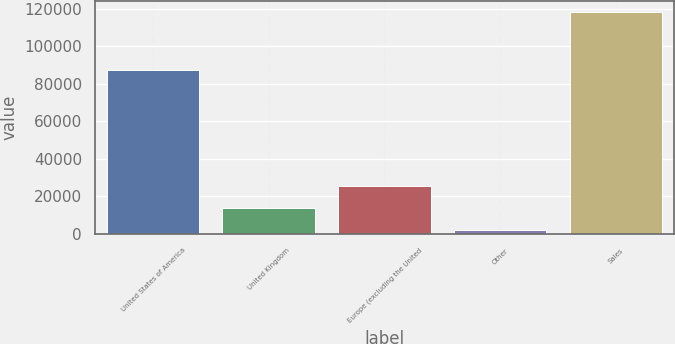Convert chart to OTSL. <chart><loc_0><loc_0><loc_500><loc_500><bar_chart><fcel>United States of America<fcel>United Kingdom<fcel>Europe (excluding the United<fcel>Other<fcel>Sales<nl><fcel>87302<fcel>13743.8<fcel>25351.6<fcel>2136<fcel>118214<nl></chart> 